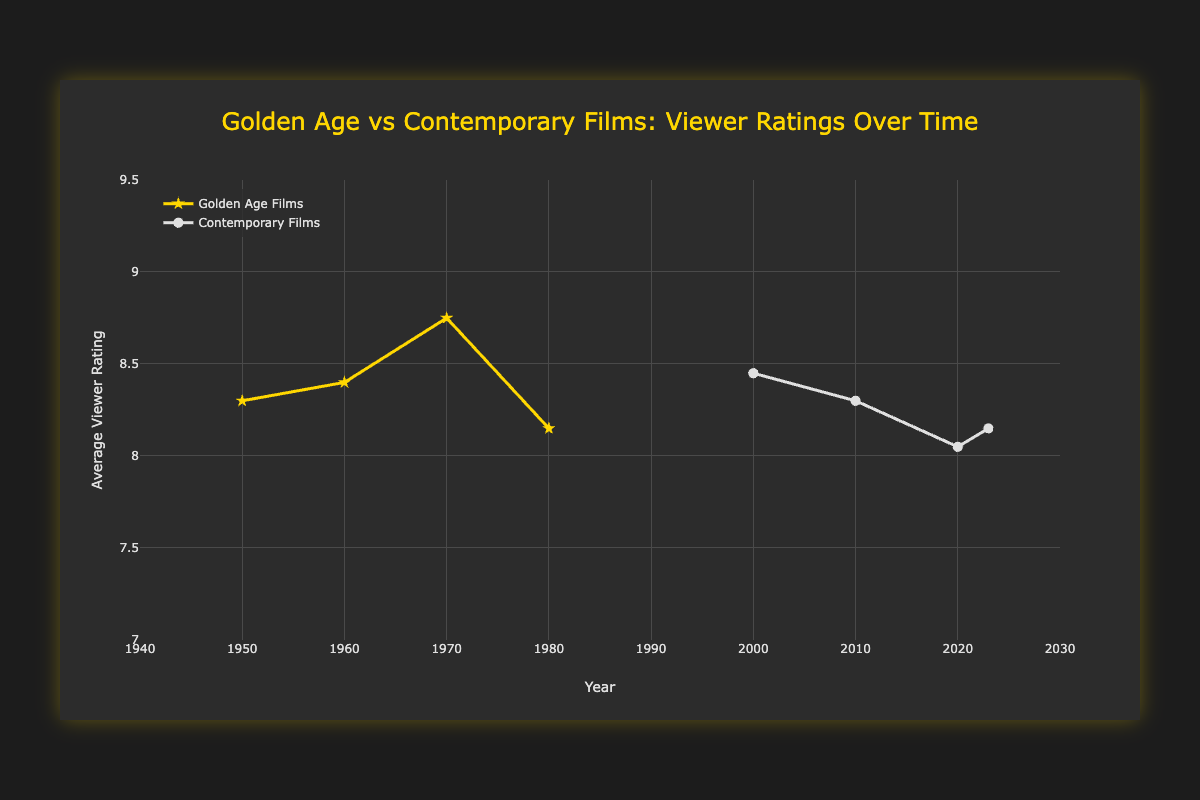What is the overall trend in viewer ratings for golden age films from the 1950s to the 1980s? Visually observe the curve corresponding to the "Golden Age Films." It appears to show a generally increasing trend, starting with ratings around 8.3 in the 1950s and reaching up to around 8.15 in the 1980s.
Answer: Increasing Which decade had the highest average viewer rating for golden age films? Visually identify the peak value along the "Golden Age Films" curve. The highest rating appears around 1970, when "The Godfather" and "A Clockwork Orange" pulled the average rating up.
Answer: 1970s What is the difference in the average viewer rating between contemporary films and golden age films in the 2020s? Observe the ratings for both golden age and contemporary films around the 2020s. Contemporary films in this period have an average rating around 8.05, while golden age films do not have data available. So we can't perform a direct comparison, showing a limitation of this dataset.
Answer: Data limitation How did the average viewer rating for contemporary films change from the 2000s to the 2010s? The average rating for contemporary films in the 2000s is around 8.45. The rating slightly increases to around 8.3 in the 2010s based on the visual trend in the curve for "Contemporary Films."
Answer: Slightly increased Compare the average viewer rating trends for "Golden Age Films" and "Contemporary Films" over time. Visually follow both curves from the leftmost point to the rightmost and compare their directions, heights, and inflection points. Golden age films exhibit an initial rise and then moderate stability, while contemporary films show an overall stable yet slightly higher trend in ratings.
Answer: Golden age rising then stable, contemporary stable During which decade did contemporary films receive their highest average viewer ratings? Observe the curve for "Contemporary Films" and pinpoint the highest peak. The highest ratings for contemporary films appear in the 2010s, showing a noticeable increase from other periods.
Answer: 2010s What is the average viewer rating for golden age films in the 1960s, and how does it compare to the average contemporary films’ rating in the 2000s? Calculate the average of 8.5 (Psycho) and 8.3 (The Apartment) for the golden age in the 1960s, which is 8.4. Compare this to the 2000s' contemporary rating, which is also around 8.45. Compared to the averages, they are roughly similar.
Answer: Roughly similar, both around 8.4 